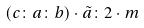<formula> <loc_0><loc_0><loc_500><loc_500>( c \colon a \colon b ) \cdot \tilde { a } \colon 2 \cdot m</formula> 